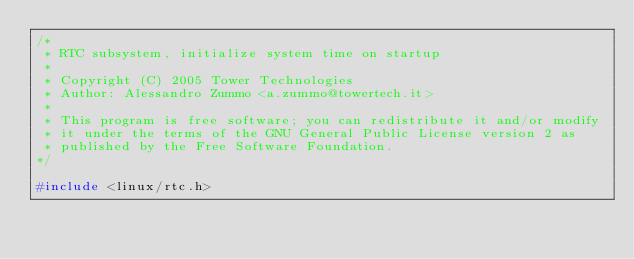<code> <loc_0><loc_0><loc_500><loc_500><_C_>/*
 * RTC subsystem, initialize system time on startup
 *
 * Copyright (C) 2005 Tower Technologies
 * Author: Alessandro Zummo <a.zummo@towertech.it>
 *
 * This program is free software; you can redistribute it and/or modify
 * it under the terms of the GNU General Public License version 2 as
 * published by the Free Software Foundation.
*/

#include <linux/rtc.h>
</code> 